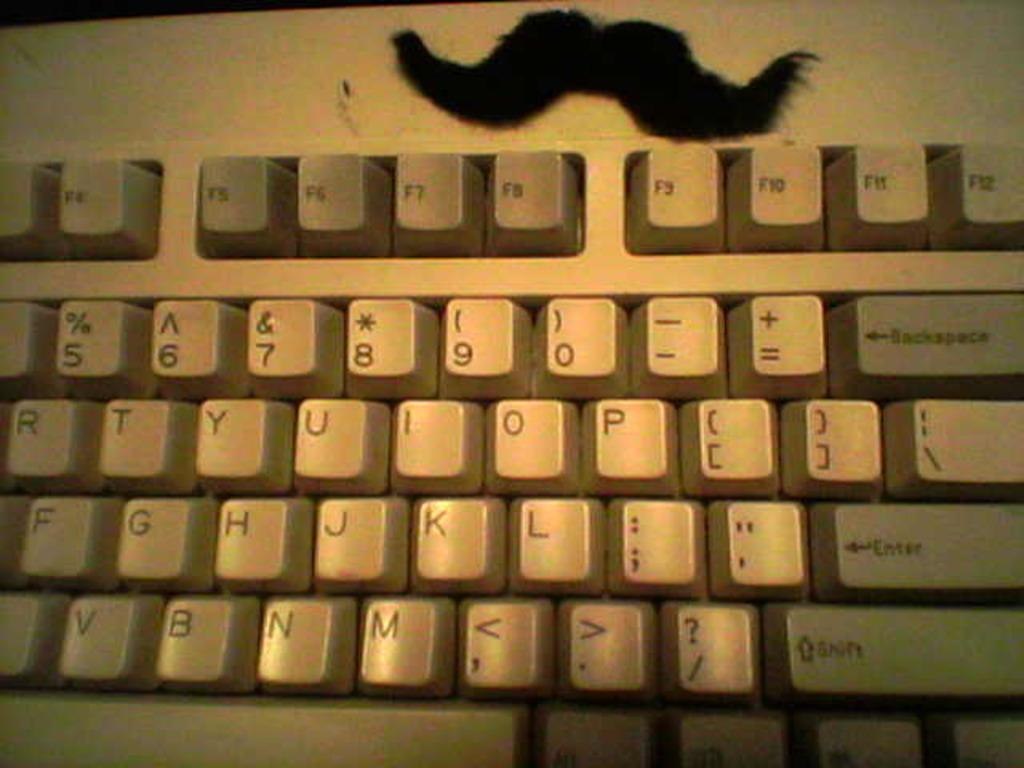<image>
Provide a brief description of the given image. A white computer keyboard with shift,enter and backspace keys. 